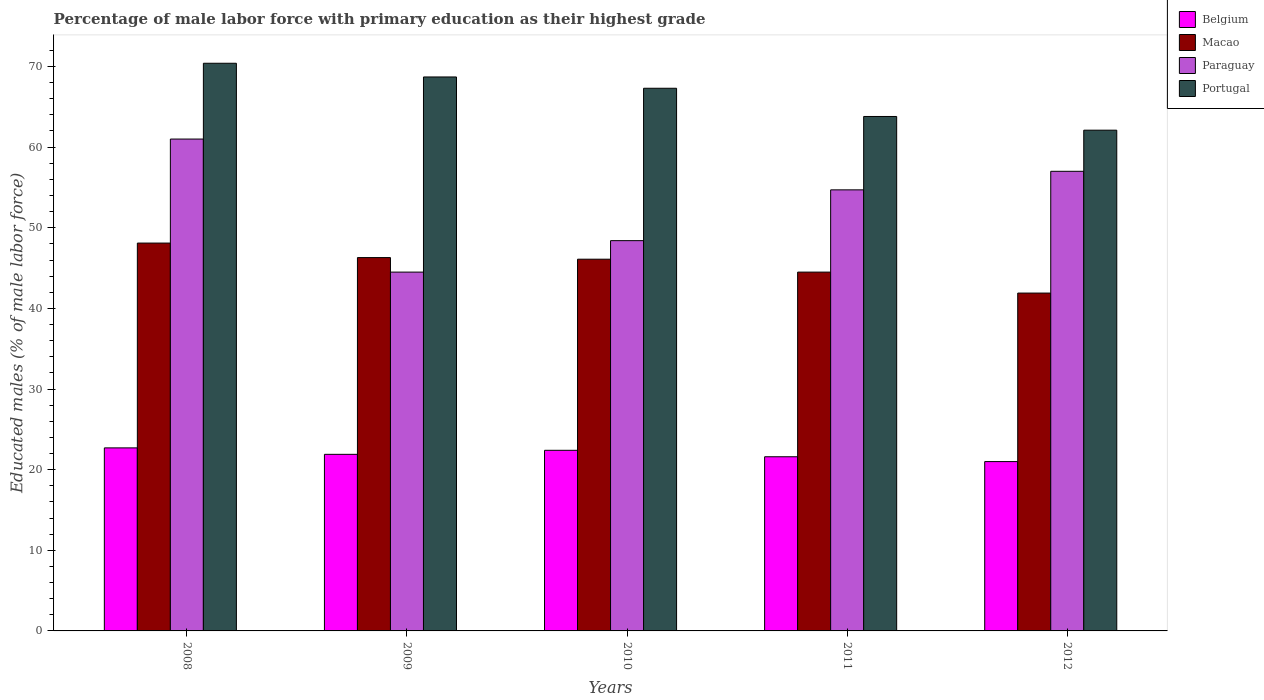How many different coloured bars are there?
Keep it short and to the point. 4. How many groups of bars are there?
Make the answer very short. 5. Are the number of bars per tick equal to the number of legend labels?
Your response must be concise. Yes. How many bars are there on the 5th tick from the left?
Provide a succinct answer. 4. How many bars are there on the 2nd tick from the right?
Provide a succinct answer. 4. What is the percentage of male labor force with primary education in Belgium in 2009?
Offer a very short reply. 21.9. Across all years, what is the maximum percentage of male labor force with primary education in Paraguay?
Keep it short and to the point. 61. In which year was the percentage of male labor force with primary education in Portugal maximum?
Keep it short and to the point. 2008. In which year was the percentage of male labor force with primary education in Macao minimum?
Offer a very short reply. 2012. What is the total percentage of male labor force with primary education in Paraguay in the graph?
Offer a terse response. 265.6. What is the difference between the percentage of male labor force with primary education in Paraguay in 2011 and that in 2012?
Your response must be concise. -2.3. What is the difference between the percentage of male labor force with primary education in Belgium in 2008 and the percentage of male labor force with primary education in Paraguay in 2011?
Give a very brief answer. -32. What is the average percentage of male labor force with primary education in Macao per year?
Your response must be concise. 45.38. In the year 2011, what is the difference between the percentage of male labor force with primary education in Macao and percentage of male labor force with primary education in Paraguay?
Give a very brief answer. -10.2. What is the ratio of the percentage of male labor force with primary education in Belgium in 2008 to that in 2012?
Make the answer very short. 1.08. Is the difference between the percentage of male labor force with primary education in Macao in 2008 and 2012 greater than the difference between the percentage of male labor force with primary education in Paraguay in 2008 and 2012?
Provide a succinct answer. Yes. What is the difference between the highest and the second highest percentage of male labor force with primary education in Macao?
Ensure brevity in your answer.  1.8. What is the difference between the highest and the lowest percentage of male labor force with primary education in Belgium?
Provide a short and direct response. 1.7. Is the sum of the percentage of male labor force with primary education in Paraguay in 2008 and 2012 greater than the maximum percentage of male labor force with primary education in Belgium across all years?
Provide a short and direct response. Yes. What does the 2nd bar from the left in 2011 represents?
Offer a very short reply. Macao. Is it the case that in every year, the sum of the percentage of male labor force with primary education in Belgium and percentage of male labor force with primary education in Portugal is greater than the percentage of male labor force with primary education in Macao?
Provide a succinct answer. Yes. How many bars are there?
Provide a succinct answer. 20. Are all the bars in the graph horizontal?
Provide a short and direct response. No. How many years are there in the graph?
Your response must be concise. 5. Are the values on the major ticks of Y-axis written in scientific E-notation?
Make the answer very short. No. Does the graph contain grids?
Offer a terse response. No. What is the title of the graph?
Give a very brief answer. Percentage of male labor force with primary education as their highest grade. Does "Monaco" appear as one of the legend labels in the graph?
Your answer should be very brief. No. What is the label or title of the X-axis?
Offer a terse response. Years. What is the label or title of the Y-axis?
Provide a short and direct response. Educated males (% of male labor force). What is the Educated males (% of male labor force) of Belgium in 2008?
Your answer should be very brief. 22.7. What is the Educated males (% of male labor force) of Macao in 2008?
Your answer should be compact. 48.1. What is the Educated males (% of male labor force) of Portugal in 2008?
Make the answer very short. 70.4. What is the Educated males (% of male labor force) of Belgium in 2009?
Your response must be concise. 21.9. What is the Educated males (% of male labor force) in Macao in 2009?
Offer a terse response. 46.3. What is the Educated males (% of male labor force) in Paraguay in 2009?
Make the answer very short. 44.5. What is the Educated males (% of male labor force) of Portugal in 2009?
Your answer should be compact. 68.7. What is the Educated males (% of male labor force) of Belgium in 2010?
Offer a terse response. 22.4. What is the Educated males (% of male labor force) of Macao in 2010?
Keep it short and to the point. 46.1. What is the Educated males (% of male labor force) in Paraguay in 2010?
Provide a short and direct response. 48.4. What is the Educated males (% of male labor force) of Portugal in 2010?
Keep it short and to the point. 67.3. What is the Educated males (% of male labor force) in Belgium in 2011?
Your answer should be very brief. 21.6. What is the Educated males (% of male labor force) in Macao in 2011?
Offer a terse response. 44.5. What is the Educated males (% of male labor force) in Paraguay in 2011?
Your response must be concise. 54.7. What is the Educated males (% of male labor force) in Portugal in 2011?
Offer a very short reply. 63.8. What is the Educated males (% of male labor force) of Belgium in 2012?
Make the answer very short. 21. What is the Educated males (% of male labor force) of Macao in 2012?
Provide a succinct answer. 41.9. What is the Educated males (% of male labor force) of Paraguay in 2012?
Your answer should be compact. 57. What is the Educated males (% of male labor force) in Portugal in 2012?
Your answer should be very brief. 62.1. Across all years, what is the maximum Educated males (% of male labor force) in Belgium?
Provide a succinct answer. 22.7. Across all years, what is the maximum Educated males (% of male labor force) in Macao?
Provide a succinct answer. 48.1. Across all years, what is the maximum Educated males (% of male labor force) of Portugal?
Your answer should be very brief. 70.4. Across all years, what is the minimum Educated males (% of male labor force) of Belgium?
Provide a short and direct response. 21. Across all years, what is the minimum Educated males (% of male labor force) in Macao?
Keep it short and to the point. 41.9. Across all years, what is the minimum Educated males (% of male labor force) of Paraguay?
Your answer should be compact. 44.5. Across all years, what is the minimum Educated males (% of male labor force) of Portugal?
Give a very brief answer. 62.1. What is the total Educated males (% of male labor force) of Belgium in the graph?
Your response must be concise. 109.6. What is the total Educated males (% of male labor force) in Macao in the graph?
Make the answer very short. 226.9. What is the total Educated males (% of male labor force) of Paraguay in the graph?
Provide a succinct answer. 265.6. What is the total Educated males (% of male labor force) in Portugal in the graph?
Offer a very short reply. 332.3. What is the difference between the Educated males (% of male labor force) in Paraguay in 2008 and that in 2009?
Provide a short and direct response. 16.5. What is the difference between the Educated males (% of male labor force) of Paraguay in 2008 and that in 2010?
Give a very brief answer. 12.6. What is the difference between the Educated males (% of male labor force) of Portugal in 2008 and that in 2010?
Give a very brief answer. 3.1. What is the difference between the Educated males (% of male labor force) of Belgium in 2008 and that in 2011?
Make the answer very short. 1.1. What is the difference between the Educated males (% of male labor force) of Portugal in 2008 and that in 2011?
Provide a short and direct response. 6.6. What is the difference between the Educated males (% of male labor force) in Belgium in 2008 and that in 2012?
Ensure brevity in your answer.  1.7. What is the difference between the Educated males (% of male labor force) of Macao in 2008 and that in 2012?
Provide a succinct answer. 6.2. What is the difference between the Educated males (% of male labor force) of Portugal in 2009 and that in 2010?
Ensure brevity in your answer.  1.4. What is the difference between the Educated males (% of male labor force) in Portugal in 2009 and that in 2012?
Provide a succinct answer. 6.6. What is the difference between the Educated males (% of male labor force) of Belgium in 2010 and that in 2011?
Keep it short and to the point. 0.8. What is the difference between the Educated males (% of male labor force) in Paraguay in 2010 and that in 2011?
Your response must be concise. -6.3. What is the difference between the Educated males (% of male labor force) in Paraguay in 2010 and that in 2012?
Your answer should be very brief. -8.6. What is the difference between the Educated males (% of male labor force) in Belgium in 2011 and that in 2012?
Your answer should be very brief. 0.6. What is the difference between the Educated males (% of male labor force) of Belgium in 2008 and the Educated males (% of male labor force) of Macao in 2009?
Make the answer very short. -23.6. What is the difference between the Educated males (% of male labor force) in Belgium in 2008 and the Educated males (% of male labor force) in Paraguay in 2009?
Give a very brief answer. -21.8. What is the difference between the Educated males (% of male labor force) in Belgium in 2008 and the Educated males (% of male labor force) in Portugal in 2009?
Your response must be concise. -46. What is the difference between the Educated males (% of male labor force) of Macao in 2008 and the Educated males (% of male labor force) of Paraguay in 2009?
Offer a terse response. 3.6. What is the difference between the Educated males (% of male labor force) of Macao in 2008 and the Educated males (% of male labor force) of Portugal in 2009?
Your answer should be very brief. -20.6. What is the difference between the Educated males (% of male labor force) of Paraguay in 2008 and the Educated males (% of male labor force) of Portugal in 2009?
Your response must be concise. -7.7. What is the difference between the Educated males (% of male labor force) in Belgium in 2008 and the Educated males (% of male labor force) in Macao in 2010?
Your answer should be compact. -23.4. What is the difference between the Educated males (% of male labor force) of Belgium in 2008 and the Educated males (% of male labor force) of Paraguay in 2010?
Your answer should be compact. -25.7. What is the difference between the Educated males (% of male labor force) of Belgium in 2008 and the Educated males (% of male labor force) of Portugal in 2010?
Offer a very short reply. -44.6. What is the difference between the Educated males (% of male labor force) in Macao in 2008 and the Educated males (% of male labor force) in Paraguay in 2010?
Offer a terse response. -0.3. What is the difference between the Educated males (% of male labor force) of Macao in 2008 and the Educated males (% of male labor force) of Portugal in 2010?
Offer a very short reply. -19.2. What is the difference between the Educated males (% of male labor force) in Belgium in 2008 and the Educated males (% of male labor force) in Macao in 2011?
Your answer should be compact. -21.8. What is the difference between the Educated males (% of male labor force) in Belgium in 2008 and the Educated males (% of male labor force) in Paraguay in 2011?
Ensure brevity in your answer.  -32. What is the difference between the Educated males (% of male labor force) of Belgium in 2008 and the Educated males (% of male labor force) of Portugal in 2011?
Provide a short and direct response. -41.1. What is the difference between the Educated males (% of male labor force) in Macao in 2008 and the Educated males (% of male labor force) in Portugal in 2011?
Offer a very short reply. -15.7. What is the difference between the Educated males (% of male labor force) in Paraguay in 2008 and the Educated males (% of male labor force) in Portugal in 2011?
Make the answer very short. -2.8. What is the difference between the Educated males (% of male labor force) in Belgium in 2008 and the Educated males (% of male labor force) in Macao in 2012?
Keep it short and to the point. -19.2. What is the difference between the Educated males (% of male labor force) in Belgium in 2008 and the Educated males (% of male labor force) in Paraguay in 2012?
Offer a terse response. -34.3. What is the difference between the Educated males (% of male labor force) in Belgium in 2008 and the Educated males (% of male labor force) in Portugal in 2012?
Your answer should be very brief. -39.4. What is the difference between the Educated males (% of male labor force) in Macao in 2008 and the Educated males (% of male labor force) in Paraguay in 2012?
Provide a succinct answer. -8.9. What is the difference between the Educated males (% of male labor force) of Macao in 2008 and the Educated males (% of male labor force) of Portugal in 2012?
Keep it short and to the point. -14. What is the difference between the Educated males (% of male labor force) of Paraguay in 2008 and the Educated males (% of male labor force) of Portugal in 2012?
Your answer should be compact. -1.1. What is the difference between the Educated males (% of male labor force) in Belgium in 2009 and the Educated males (% of male labor force) in Macao in 2010?
Offer a terse response. -24.2. What is the difference between the Educated males (% of male labor force) in Belgium in 2009 and the Educated males (% of male labor force) in Paraguay in 2010?
Your answer should be very brief. -26.5. What is the difference between the Educated males (% of male labor force) of Belgium in 2009 and the Educated males (% of male labor force) of Portugal in 2010?
Your response must be concise. -45.4. What is the difference between the Educated males (% of male labor force) of Macao in 2009 and the Educated males (% of male labor force) of Paraguay in 2010?
Offer a very short reply. -2.1. What is the difference between the Educated males (% of male labor force) in Paraguay in 2009 and the Educated males (% of male labor force) in Portugal in 2010?
Keep it short and to the point. -22.8. What is the difference between the Educated males (% of male labor force) in Belgium in 2009 and the Educated males (% of male labor force) in Macao in 2011?
Your answer should be compact. -22.6. What is the difference between the Educated males (% of male labor force) in Belgium in 2009 and the Educated males (% of male labor force) in Paraguay in 2011?
Your answer should be compact. -32.8. What is the difference between the Educated males (% of male labor force) of Belgium in 2009 and the Educated males (% of male labor force) of Portugal in 2011?
Your answer should be compact. -41.9. What is the difference between the Educated males (% of male labor force) in Macao in 2009 and the Educated males (% of male labor force) in Paraguay in 2011?
Keep it short and to the point. -8.4. What is the difference between the Educated males (% of male labor force) of Macao in 2009 and the Educated males (% of male labor force) of Portugal in 2011?
Offer a very short reply. -17.5. What is the difference between the Educated males (% of male labor force) in Paraguay in 2009 and the Educated males (% of male labor force) in Portugal in 2011?
Your response must be concise. -19.3. What is the difference between the Educated males (% of male labor force) in Belgium in 2009 and the Educated males (% of male labor force) in Macao in 2012?
Offer a very short reply. -20. What is the difference between the Educated males (% of male labor force) in Belgium in 2009 and the Educated males (% of male labor force) in Paraguay in 2012?
Provide a succinct answer. -35.1. What is the difference between the Educated males (% of male labor force) of Belgium in 2009 and the Educated males (% of male labor force) of Portugal in 2012?
Your answer should be compact. -40.2. What is the difference between the Educated males (% of male labor force) of Macao in 2009 and the Educated males (% of male labor force) of Paraguay in 2012?
Ensure brevity in your answer.  -10.7. What is the difference between the Educated males (% of male labor force) of Macao in 2009 and the Educated males (% of male labor force) of Portugal in 2012?
Your response must be concise. -15.8. What is the difference between the Educated males (% of male labor force) in Paraguay in 2009 and the Educated males (% of male labor force) in Portugal in 2012?
Give a very brief answer. -17.6. What is the difference between the Educated males (% of male labor force) in Belgium in 2010 and the Educated males (% of male labor force) in Macao in 2011?
Make the answer very short. -22.1. What is the difference between the Educated males (% of male labor force) of Belgium in 2010 and the Educated males (% of male labor force) of Paraguay in 2011?
Your answer should be compact. -32.3. What is the difference between the Educated males (% of male labor force) in Belgium in 2010 and the Educated males (% of male labor force) in Portugal in 2011?
Provide a succinct answer. -41.4. What is the difference between the Educated males (% of male labor force) of Macao in 2010 and the Educated males (% of male labor force) of Paraguay in 2011?
Your answer should be compact. -8.6. What is the difference between the Educated males (% of male labor force) of Macao in 2010 and the Educated males (% of male labor force) of Portugal in 2011?
Make the answer very short. -17.7. What is the difference between the Educated males (% of male labor force) of Paraguay in 2010 and the Educated males (% of male labor force) of Portugal in 2011?
Make the answer very short. -15.4. What is the difference between the Educated males (% of male labor force) of Belgium in 2010 and the Educated males (% of male labor force) of Macao in 2012?
Your answer should be very brief. -19.5. What is the difference between the Educated males (% of male labor force) in Belgium in 2010 and the Educated males (% of male labor force) in Paraguay in 2012?
Provide a short and direct response. -34.6. What is the difference between the Educated males (% of male labor force) of Belgium in 2010 and the Educated males (% of male labor force) of Portugal in 2012?
Ensure brevity in your answer.  -39.7. What is the difference between the Educated males (% of male labor force) in Paraguay in 2010 and the Educated males (% of male labor force) in Portugal in 2012?
Your answer should be compact. -13.7. What is the difference between the Educated males (% of male labor force) of Belgium in 2011 and the Educated males (% of male labor force) of Macao in 2012?
Keep it short and to the point. -20.3. What is the difference between the Educated males (% of male labor force) of Belgium in 2011 and the Educated males (% of male labor force) of Paraguay in 2012?
Ensure brevity in your answer.  -35.4. What is the difference between the Educated males (% of male labor force) of Belgium in 2011 and the Educated males (% of male labor force) of Portugal in 2012?
Provide a short and direct response. -40.5. What is the difference between the Educated males (% of male labor force) in Macao in 2011 and the Educated males (% of male labor force) in Paraguay in 2012?
Offer a very short reply. -12.5. What is the difference between the Educated males (% of male labor force) in Macao in 2011 and the Educated males (% of male labor force) in Portugal in 2012?
Give a very brief answer. -17.6. What is the difference between the Educated males (% of male labor force) in Paraguay in 2011 and the Educated males (% of male labor force) in Portugal in 2012?
Your answer should be compact. -7.4. What is the average Educated males (% of male labor force) of Belgium per year?
Your answer should be compact. 21.92. What is the average Educated males (% of male labor force) of Macao per year?
Your answer should be compact. 45.38. What is the average Educated males (% of male labor force) of Paraguay per year?
Offer a terse response. 53.12. What is the average Educated males (% of male labor force) of Portugal per year?
Offer a very short reply. 66.46. In the year 2008, what is the difference between the Educated males (% of male labor force) of Belgium and Educated males (% of male labor force) of Macao?
Your response must be concise. -25.4. In the year 2008, what is the difference between the Educated males (% of male labor force) in Belgium and Educated males (% of male labor force) in Paraguay?
Keep it short and to the point. -38.3. In the year 2008, what is the difference between the Educated males (% of male labor force) in Belgium and Educated males (% of male labor force) in Portugal?
Give a very brief answer. -47.7. In the year 2008, what is the difference between the Educated males (% of male labor force) in Macao and Educated males (% of male labor force) in Paraguay?
Ensure brevity in your answer.  -12.9. In the year 2008, what is the difference between the Educated males (% of male labor force) in Macao and Educated males (% of male labor force) in Portugal?
Make the answer very short. -22.3. In the year 2008, what is the difference between the Educated males (% of male labor force) of Paraguay and Educated males (% of male labor force) of Portugal?
Your answer should be very brief. -9.4. In the year 2009, what is the difference between the Educated males (% of male labor force) of Belgium and Educated males (% of male labor force) of Macao?
Offer a very short reply. -24.4. In the year 2009, what is the difference between the Educated males (% of male labor force) in Belgium and Educated males (% of male labor force) in Paraguay?
Provide a succinct answer. -22.6. In the year 2009, what is the difference between the Educated males (% of male labor force) in Belgium and Educated males (% of male labor force) in Portugal?
Keep it short and to the point. -46.8. In the year 2009, what is the difference between the Educated males (% of male labor force) of Macao and Educated males (% of male labor force) of Portugal?
Ensure brevity in your answer.  -22.4. In the year 2009, what is the difference between the Educated males (% of male labor force) of Paraguay and Educated males (% of male labor force) of Portugal?
Keep it short and to the point. -24.2. In the year 2010, what is the difference between the Educated males (% of male labor force) of Belgium and Educated males (% of male labor force) of Macao?
Offer a very short reply. -23.7. In the year 2010, what is the difference between the Educated males (% of male labor force) of Belgium and Educated males (% of male labor force) of Portugal?
Make the answer very short. -44.9. In the year 2010, what is the difference between the Educated males (% of male labor force) in Macao and Educated males (% of male labor force) in Paraguay?
Offer a terse response. -2.3. In the year 2010, what is the difference between the Educated males (% of male labor force) of Macao and Educated males (% of male labor force) of Portugal?
Give a very brief answer. -21.2. In the year 2010, what is the difference between the Educated males (% of male labor force) in Paraguay and Educated males (% of male labor force) in Portugal?
Ensure brevity in your answer.  -18.9. In the year 2011, what is the difference between the Educated males (% of male labor force) in Belgium and Educated males (% of male labor force) in Macao?
Offer a very short reply. -22.9. In the year 2011, what is the difference between the Educated males (% of male labor force) of Belgium and Educated males (% of male labor force) of Paraguay?
Make the answer very short. -33.1. In the year 2011, what is the difference between the Educated males (% of male labor force) in Belgium and Educated males (% of male labor force) in Portugal?
Your answer should be very brief. -42.2. In the year 2011, what is the difference between the Educated males (% of male labor force) in Macao and Educated males (% of male labor force) in Portugal?
Your answer should be very brief. -19.3. In the year 2011, what is the difference between the Educated males (% of male labor force) in Paraguay and Educated males (% of male labor force) in Portugal?
Make the answer very short. -9.1. In the year 2012, what is the difference between the Educated males (% of male labor force) of Belgium and Educated males (% of male labor force) of Macao?
Make the answer very short. -20.9. In the year 2012, what is the difference between the Educated males (% of male labor force) of Belgium and Educated males (% of male labor force) of Paraguay?
Give a very brief answer. -36. In the year 2012, what is the difference between the Educated males (% of male labor force) in Belgium and Educated males (% of male labor force) in Portugal?
Provide a short and direct response. -41.1. In the year 2012, what is the difference between the Educated males (% of male labor force) in Macao and Educated males (% of male labor force) in Paraguay?
Make the answer very short. -15.1. In the year 2012, what is the difference between the Educated males (% of male labor force) in Macao and Educated males (% of male labor force) in Portugal?
Your answer should be compact. -20.2. In the year 2012, what is the difference between the Educated males (% of male labor force) in Paraguay and Educated males (% of male labor force) in Portugal?
Provide a succinct answer. -5.1. What is the ratio of the Educated males (% of male labor force) of Belgium in 2008 to that in 2009?
Offer a very short reply. 1.04. What is the ratio of the Educated males (% of male labor force) in Macao in 2008 to that in 2009?
Your response must be concise. 1.04. What is the ratio of the Educated males (% of male labor force) of Paraguay in 2008 to that in 2009?
Keep it short and to the point. 1.37. What is the ratio of the Educated males (% of male labor force) of Portugal in 2008 to that in 2009?
Give a very brief answer. 1.02. What is the ratio of the Educated males (% of male labor force) of Belgium in 2008 to that in 2010?
Ensure brevity in your answer.  1.01. What is the ratio of the Educated males (% of male labor force) of Macao in 2008 to that in 2010?
Give a very brief answer. 1.04. What is the ratio of the Educated males (% of male labor force) of Paraguay in 2008 to that in 2010?
Make the answer very short. 1.26. What is the ratio of the Educated males (% of male labor force) of Portugal in 2008 to that in 2010?
Ensure brevity in your answer.  1.05. What is the ratio of the Educated males (% of male labor force) in Belgium in 2008 to that in 2011?
Keep it short and to the point. 1.05. What is the ratio of the Educated males (% of male labor force) in Macao in 2008 to that in 2011?
Your answer should be very brief. 1.08. What is the ratio of the Educated males (% of male labor force) in Paraguay in 2008 to that in 2011?
Your response must be concise. 1.12. What is the ratio of the Educated males (% of male labor force) in Portugal in 2008 to that in 2011?
Keep it short and to the point. 1.1. What is the ratio of the Educated males (% of male labor force) of Belgium in 2008 to that in 2012?
Offer a terse response. 1.08. What is the ratio of the Educated males (% of male labor force) in Macao in 2008 to that in 2012?
Offer a very short reply. 1.15. What is the ratio of the Educated males (% of male labor force) in Paraguay in 2008 to that in 2012?
Provide a short and direct response. 1.07. What is the ratio of the Educated males (% of male labor force) in Portugal in 2008 to that in 2012?
Provide a succinct answer. 1.13. What is the ratio of the Educated males (% of male labor force) of Belgium in 2009 to that in 2010?
Make the answer very short. 0.98. What is the ratio of the Educated males (% of male labor force) in Macao in 2009 to that in 2010?
Your answer should be compact. 1. What is the ratio of the Educated males (% of male labor force) in Paraguay in 2009 to that in 2010?
Make the answer very short. 0.92. What is the ratio of the Educated males (% of male labor force) in Portugal in 2009 to that in 2010?
Provide a short and direct response. 1.02. What is the ratio of the Educated males (% of male labor force) in Belgium in 2009 to that in 2011?
Keep it short and to the point. 1.01. What is the ratio of the Educated males (% of male labor force) in Macao in 2009 to that in 2011?
Make the answer very short. 1.04. What is the ratio of the Educated males (% of male labor force) of Paraguay in 2009 to that in 2011?
Provide a succinct answer. 0.81. What is the ratio of the Educated males (% of male labor force) in Portugal in 2009 to that in 2011?
Keep it short and to the point. 1.08. What is the ratio of the Educated males (% of male labor force) of Belgium in 2009 to that in 2012?
Provide a short and direct response. 1.04. What is the ratio of the Educated males (% of male labor force) in Macao in 2009 to that in 2012?
Give a very brief answer. 1.1. What is the ratio of the Educated males (% of male labor force) in Paraguay in 2009 to that in 2012?
Ensure brevity in your answer.  0.78. What is the ratio of the Educated males (% of male labor force) in Portugal in 2009 to that in 2012?
Your answer should be compact. 1.11. What is the ratio of the Educated males (% of male labor force) in Belgium in 2010 to that in 2011?
Provide a succinct answer. 1.04. What is the ratio of the Educated males (% of male labor force) in Macao in 2010 to that in 2011?
Make the answer very short. 1.04. What is the ratio of the Educated males (% of male labor force) in Paraguay in 2010 to that in 2011?
Make the answer very short. 0.88. What is the ratio of the Educated males (% of male labor force) in Portugal in 2010 to that in 2011?
Offer a very short reply. 1.05. What is the ratio of the Educated males (% of male labor force) of Belgium in 2010 to that in 2012?
Your response must be concise. 1.07. What is the ratio of the Educated males (% of male labor force) in Macao in 2010 to that in 2012?
Your answer should be very brief. 1.1. What is the ratio of the Educated males (% of male labor force) in Paraguay in 2010 to that in 2012?
Keep it short and to the point. 0.85. What is the ratio of the Educated males (% of male labor force) in Portugal in 2010 to that in 2012?
Make the answer very short. 1.08. What is the ratio of the Educated males (% of male labor force) of Belgium in 2011 to that in 2012?
Your answer should be very brief. 1.03. What is the ratio of the Educated males (% of male labor force) of Macao in 2011 to that in 2012?
Offer a terse response. 1.06. What is the ratio of the Educated males (% of male labor force) in Paraguay in 2011 to that in 2012?
Provide a succinct answer. 0.96. What is the ratio of the Educated males (% of male labor force) of Portugal in 2011 to that in 2012?
Your response must be concise. 1.03. What is the difference between the highest and the second highest Educated males (% of male labor force) of Paraguay?
Your answer should be compact. 4. What is the difference between the highest and the lowest Educated males (% of male labor force) of Belgium?
Ensure brevity in your answer.  1.7. 